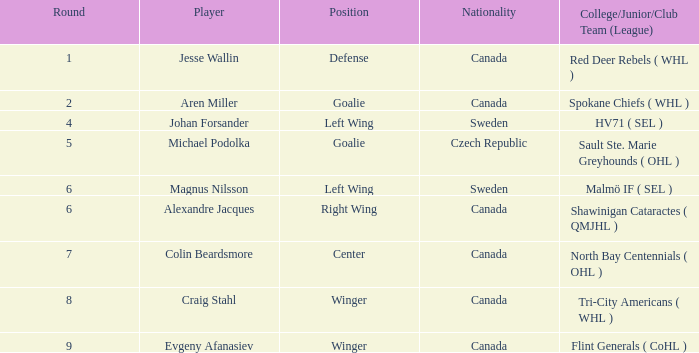Which canadian school, junior, or club group class has a position of goalie? Spokane Chiefs ( WHL ). 